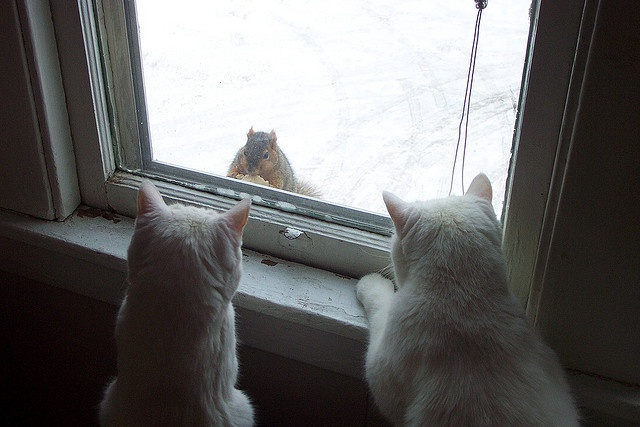Describe the objects in this image and their specific colors. I can see cat in black, gray, and darkgray tones and cat in black, gray, and darkgray tones in this image. 